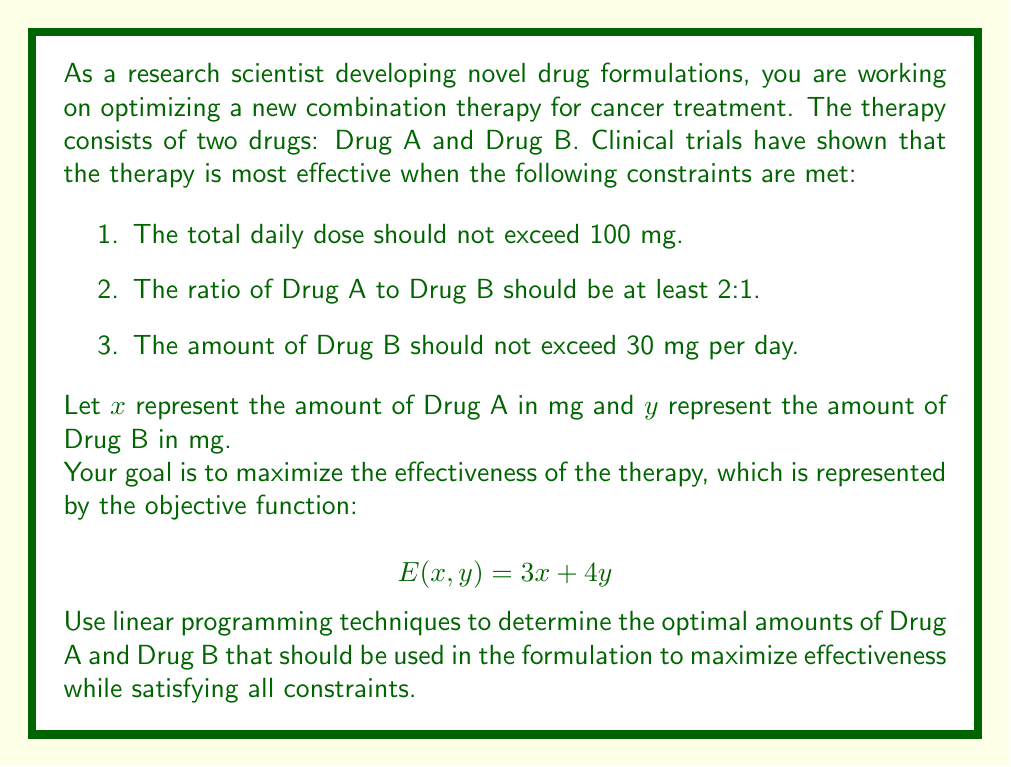Could you help me with this problem? To solve this linear programming problem, we'll follow these steps:

1. Identify the objective function and constraints
2. Graph the feasible region
3. Find the corner points of the feasible region
4. Evaluate the objective function at each corner point
5. Select the point that maximizes the objective function

Step 1: Identify the objective function and constraints

Objective function: $E(x,y) = 3x + 4y$ (maximize)

Constraints:
1. $x + y \leq 100$ (total dose)
2. $x \geq 2y$ (ratio of Drug A to Drug B)
3. $y \leq 30$ (maximum amount of Drug B)
4. $x \geq 0$, $y \geq 0$ (non-negativity constraints)

Step 2: Graph the feasible region

We'll use Asymptote to graph the constraints and feasible region:

[asy]
import graph;
size(200);

xaxis("x", 0, 100, Arrow);
yaxis("y", 0, 50, Arrow);

draw((0,30)--(100,30), blue);
draw((0,0)--(50,50), red);
draw((0,0)--(100,0), green);
draw((100,0)--(0,100), purple);

fill((0,0)--(0,30)--(40,30)--(66.67,33.33)--(100,0)--cycle, palegreen+opacity(0.2));

label("$y=30$", (50,32), N, blue);
label("$x=2y$", (30,15), NW, red);
label("$x+y=100$", (80,20), NW, purple);

dot((0,0));
dot((0,30));
dot((40,30));
dot((66.67,33.33));
dot((100,0));

label("(0,0)", (0,0), SW);
label("(0,30)", (0,30), W);
label("(40,30)", (40,30), NE);
label("(66.67,33.33)", (66.67,33.33), NE);
label("(100,0)", (100,0), SE);
[/asy]

Step 3: Find the corner points of the feasible region

The corner points are:
1. (0, 0)
2. (0, 30)
3. (40, 30)
4. (66.67, 33.33)
5. (100, 0)

Step 4: Evaluate the objective function at each corner point

1. $E(0, 0) = 3(0) + 4(0) = 0$
2. $E(0, 30) = 3(0) + 4(30) = 120$
3. $E(40, 30) = 3(40) + 4(30) = 240$
4. $E(66.67, 33.33) = 3(66.67) + 4(33.33) \approx 333.33$
5. $E(100, 0) = 3(100) + 4(0) = 300$

Step 5: Select the point that maximizes the objective function

The point (66.67, 33.33) gives the maximum value of the objective function, approximately 333.33.

Therefore, the optimal formulation is approximately 66.67 mg of Drug A and 33.33 mg of Drug B.
Answer: The optimal drug formulation is approximately 66.67 mg of Drug A and 33.33 mg of Drug B, which maximizes the effectiveness function $E(x,y)$ at approximately 333.33. 